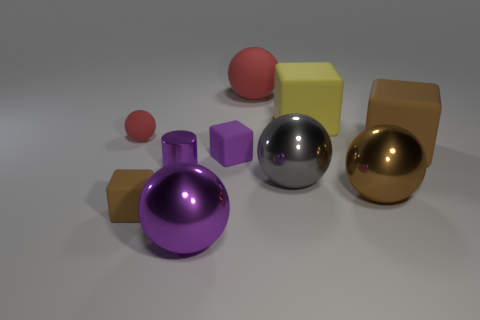How many red rubber things are the same shape as the brown metal object?
Your response must be concise. 2. Are there any things of the same color as the cylinder?
Provide a short and direct response. Yes. How many objects are either objects in front of the small matte sphere or red matte objects that are to the right of the small purple rubber cube?
Provide a succinct answer. 8. Is there a gray shiny ball that is on the left side of the brown cube that is in front of the big brown rubber block?
Your answer should be very brief. No. There is a yellow rubber thing that is the same size as the gray shiny thing; what is its shape?
Give a very brief answer. Cube. How many objects are purple things that are to the left of the big purple object or gray metallic things?
Provide a short and direct response. 2. What number of other objects are the same material as the purple cylinder?
Offer a terse response. 3. The object that is the same color as the small matte ball is what shape?
Provide a short and direct response. Sphere. What is the size of the red rubber sphere that is to the left of the big purple metal object?
Provide a succinct answer. Small. What is the shape of the purple object that is made of the same material as the tiny red object?
Your answer should be compact. Cube. 